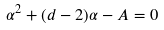Convert formula to latex. <formula><loc_0><loc_0><loc_500><loc_500>\alpha ^ { 2 } + ( d - 2 ) \alpha - A = 0</formula> 